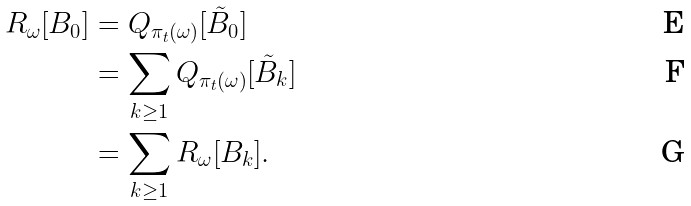Convert formula to latex. <formula><loc_0><loc_0><loc_500><loc_500>R _ { \omega } [ B _ { 0 } ] & = Q _ { \pi _ { t } ( \omega ) } [ \tilde { B } _ { 0 } ] \\ & = \sum _ { k \geq 1 } Q _ { \pi _ { t } ( \omega ) } [ \tilde { B } _ { k } ] \\ & = \sum _ { k \geq 1 } R _ { \omega } [ B _ { k } ] .</formula> 